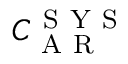<formula> <loc_0><loc_0><loc_500><loc_500>C _ { A R } ^ { S Y S }</formula> 